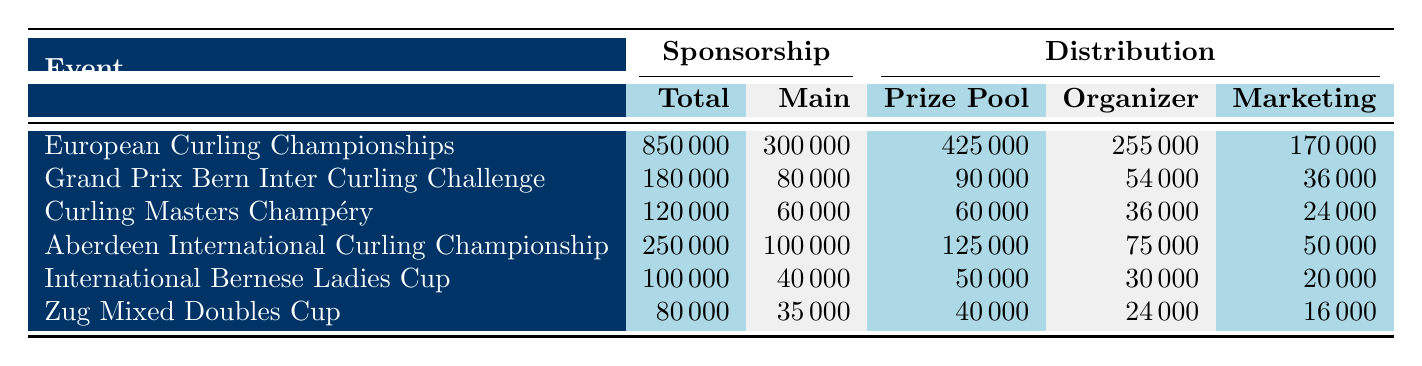What is the total sponsorship amount for the Grand Prix Bern Inter Curling Challenge? The table shows that the total sponsorship amount for the Grand Prix Bern Inter Curling Challenge is listed under the 'Sponsorship' section. According to the table, this value is 180,000.
Answer: 180000 Which event has the highest total sponsorship? To find the event with the highest total sponsorship, we need to compare the total sponsorship amounts across all events. The European Curling Championships has the highest total sponsorship at 850,000.
Answer: European Curling Championships What percentage of the total sponsorship for the Zug Mixed Doubles Cup is contributed by the main sponsor? The total sponsorship for the Zug Mixed Doubles Cup is 80,000, and the main sponsor contribution is 35,000. To find the percentage, we calculate (35,000 / 80,000) * 100, which equals 43.75%.
Answer: 43.75% Did the prize pool for the International Bernese Ladies Cup exceed the organizer's share? The prize pool for the International Bernese Ladies Cup is 50,000, while the organizer's share is 30,000. Since 50,000 is greater than 30,000, the answer is yes.
Answer: Yes What is the total sponsorship amount for all events combined, and what is the average sponsorship amount per event? To find the total sponsorship amount, we sum the total sponsorships: 850,000 + 180,000 + 120,000 + 250,000 + 100,000 + 80,000 = 1,580,000. There are 6 events, so the average is 1,580,000 / 6, which equals 263,333.33.
Answer: Total: 1580000, Average: 263333.33 Which event had a higher marketing expense: the Curling Masters Champéry or the Zug Mixed Doubles Cup? The Curling Masters Champéry has marketing expenses of 24,000, while the Zug Mixed Doubles Cup has marketing expenses of 16,000. Since 24,000 is greater than 16,000, Curling Masters Champéry had higher marketing expenses.
Answer: Curling Masters Champéry What is the combined total sponsorship amount for events held in Switzerland? The events held in Switzerland are Grand Prix Bern Inter Curling Challenge, Curling Masters Champéry, and Zug Mixed Doubles Cup with total sponsorship amounts of 180,000, 120,000, and 80,000 respectively. Summing these gives 180,000 + 120,000 + 80,000 = 380,000.
Answer: 380000 Is the sponsorship amount for the Aberdeen International Curling Championship less than the total prize pool for that event? The total sponsorship for the Aberdeen International Curling Championship is 250,000, and the prize pool is 125,000. Since 250,000 is greater than 125,000, the answer is no.
Answer: No 